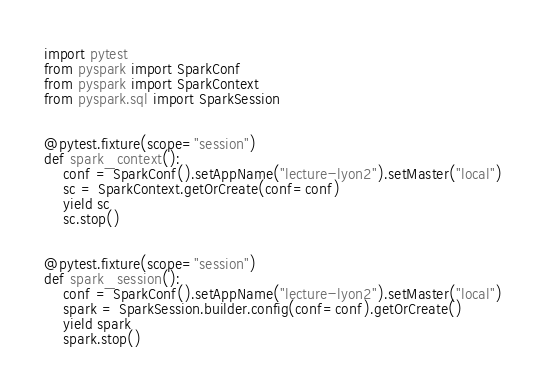<code> <loc_0><loc_0><loc_500><loc_500><_Python_>import pytest
from pyspark import SparkConf
from pyspark import SparkContext
from pyspark.sql import SparkSession


@pytest.fixture(scope="session")
def spark_context():
    conf = SparkConf().setAppName("lecture-lyon2").setMaster("local")
    sc = SparkContext.getOrCreate(conf=conf)
    yield sc
    sc.stop()


@pytest.fixture(scope="session")
def spark_session():
    conf = SparkConf().setAppName("lecture-lyon2").setMaster("local")
    spark = SparkSession.builder.config(conf=conf).getOrCreate()
    yield spark
    spark.stop()

</code> 